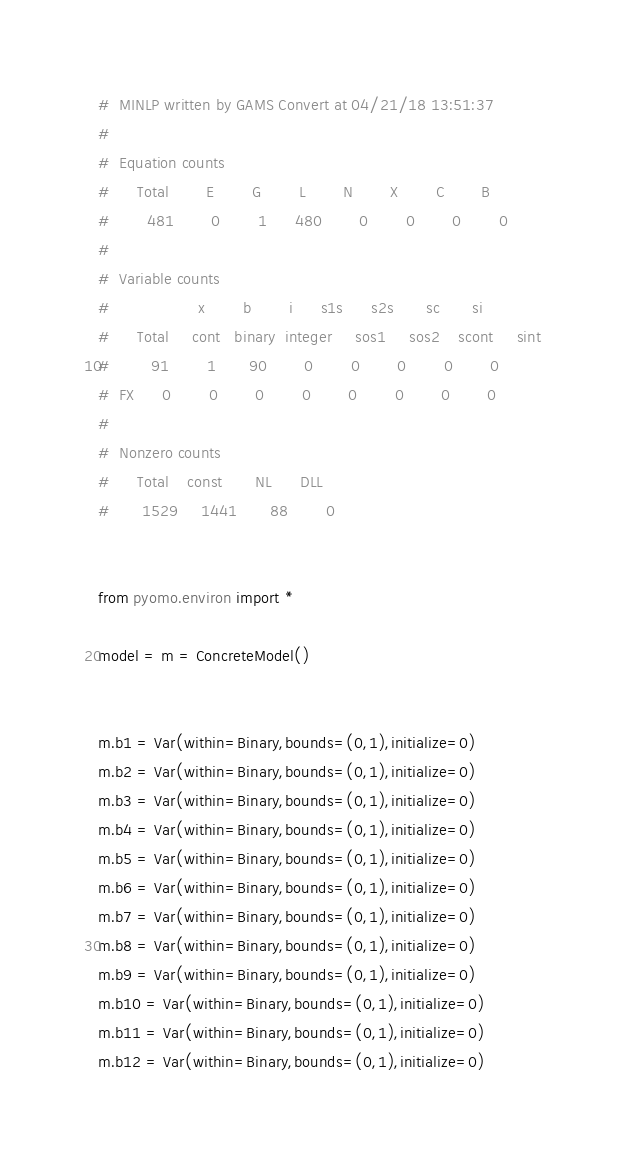<code> <loc_0><loc_0><loc_500><loc_500><_Python_>#  MINLP written by GAMS Convert at 04/21/18 13:51:37
#  
#  Equation counts
#      Total        E        G        L        N        X        C        B
#        481        0        1      480        0        0        0        0
#  
#  Variable counts
#                   x        b        i      s1s      s2s       sc       si
#      Total     cont   binary  integer     sos1     sos2    scont     sint
#         91        1       90        0        0        0        0        0
#  FX      0        0        0        0        0        0        0        0
#  
#  Nonzero counts
#      Total    const       NL      DLL
#       1529     1441       88        0


from pyomo.environ import *

model = m = ConcreteModel()


m.b1 = Var(within=Binary,bounds=(0,1),initialize=0)
m.b2 = Var(within=Binary,bounds=(0,1),initialize=0)
m.b3 = Var(within=Binary,bounds=(0,1),initialize=0)
m.b4 = Var(within=Binary,bounds=(0,1),initialize=0)
m.b5 = Var(within=Binary,bounds=(0,1),initialize=0)
m.b6 = Var(within=Binary,bounds=(0,1),initialize=0)
m.b7 = Var(within=Binary,bounds=(0,1),initialize=0)
m.b8 = Var(within=Binary,bounds=(0,1),initialize=0)
m.b9 = Var(within=Binary,bounds=(0,1),initialize=0)
m.b10 = Var(within=Binary,bounds=(0,1),initialize=0)
m.b11 = Var(within=Binary,bounds=(0,1),initialize=0)
m.b12 = Var(within=Binary,bounds=(0,1),initialize=0)</code> 